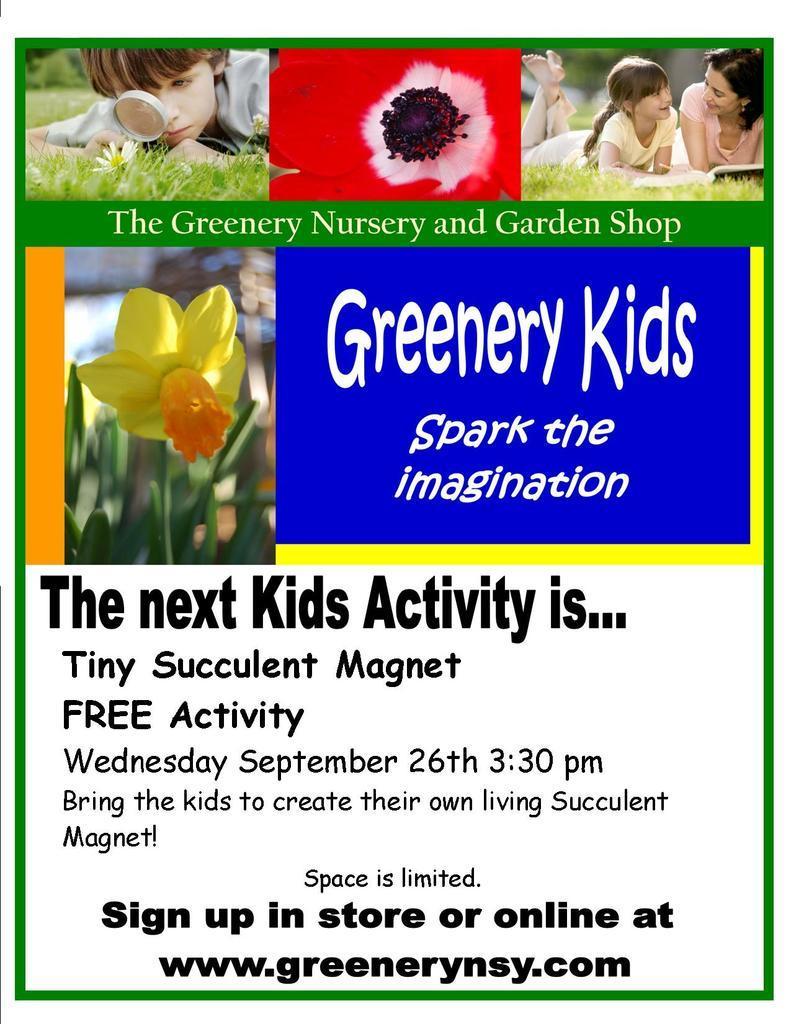Describe this image in one or two sentences. This is the picture of the poster. In this picture, we see a yellow flower. The boy and the two girls are lying on the grass. At the bottom, we see some text written. 